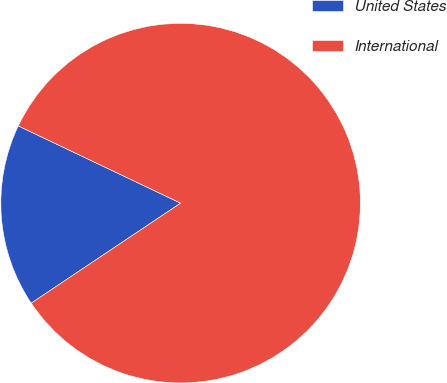<chart> <loc_0><loc_0><loc_500><loc_500><pie_chart><fcel>United States<fcel>International<nl><fcel>16.46%<fcel>83.54%<nl></chart> 